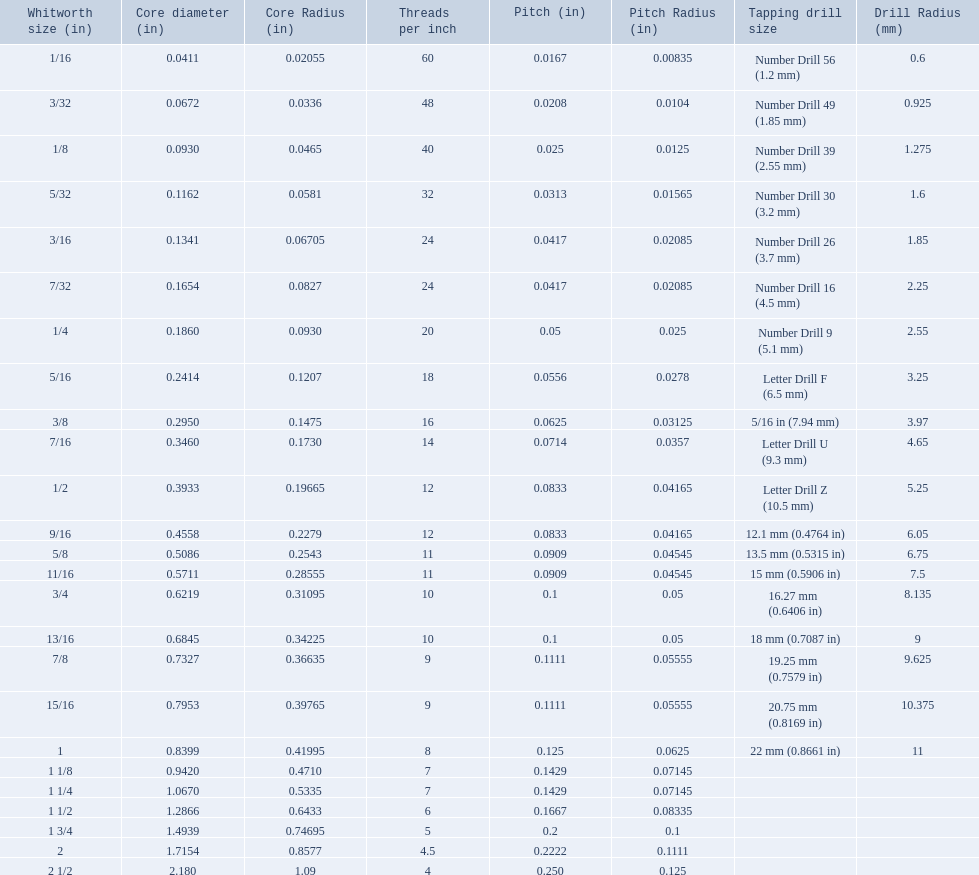What are the whitworth sizes? 1/16, 3/32, 1/8, 5/32, 3/16, 7/32, 1/4, 5/16, 3/8, 7/16, 1/2, 9/16, 5/8, 11/16, 3/4, 13/16, 7/8, 15/16, 1, 1 1/8, 1 1/4, 1 1/2, 1 3/4, 2, 2 1/2. And their threads per inch? 60, 48, 40, 32, 24, 24, 20, 18, 16, 14, 12, 12, 11, 11, 10, 10, 9, 9, 8, 7, 7, 6, 5, 4.5, 4. Now, which whitworth size has a thread-per-inch size of 5?? 1 3/4. 